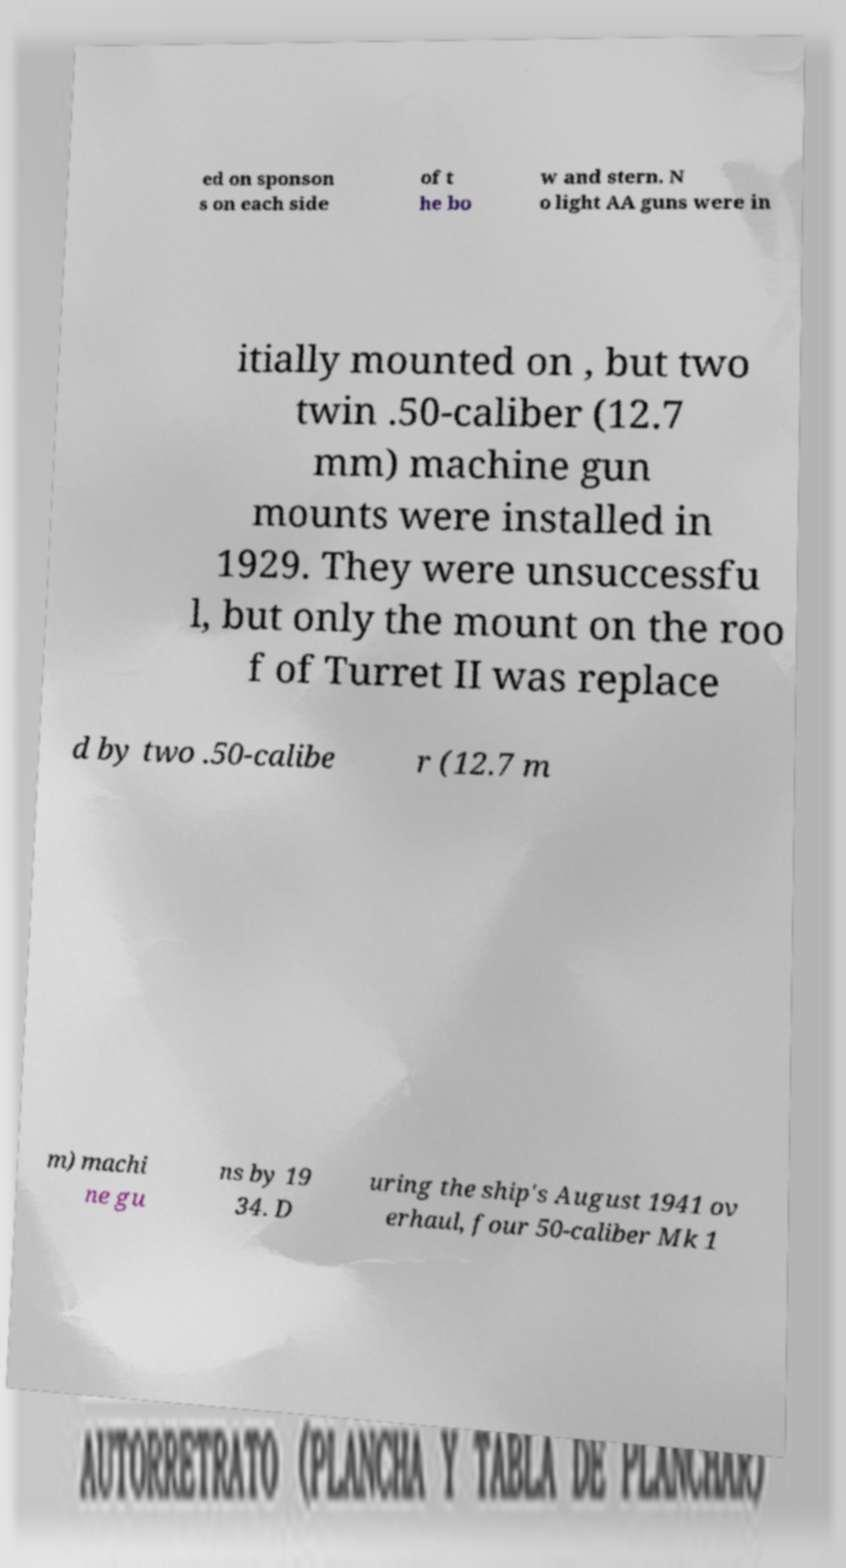There's text embedded in this image that I need extracted. Can you transcribe it verbatim? ed on sponson s on each side of t he bo w and stern. N o light AA guns were in itially mounted on , but two twin .50-caliber (12.7 mm) machine gun mounts were installed in 1929. They were unsuccessfu l, but only the mount on the roo f of Turret II was replace d by two .50-calibe r (12.7 m m) machi ne gu ns by 19 34. D uring the ship's August 1941 ov erhaul, four 50-caliber Mk 1 